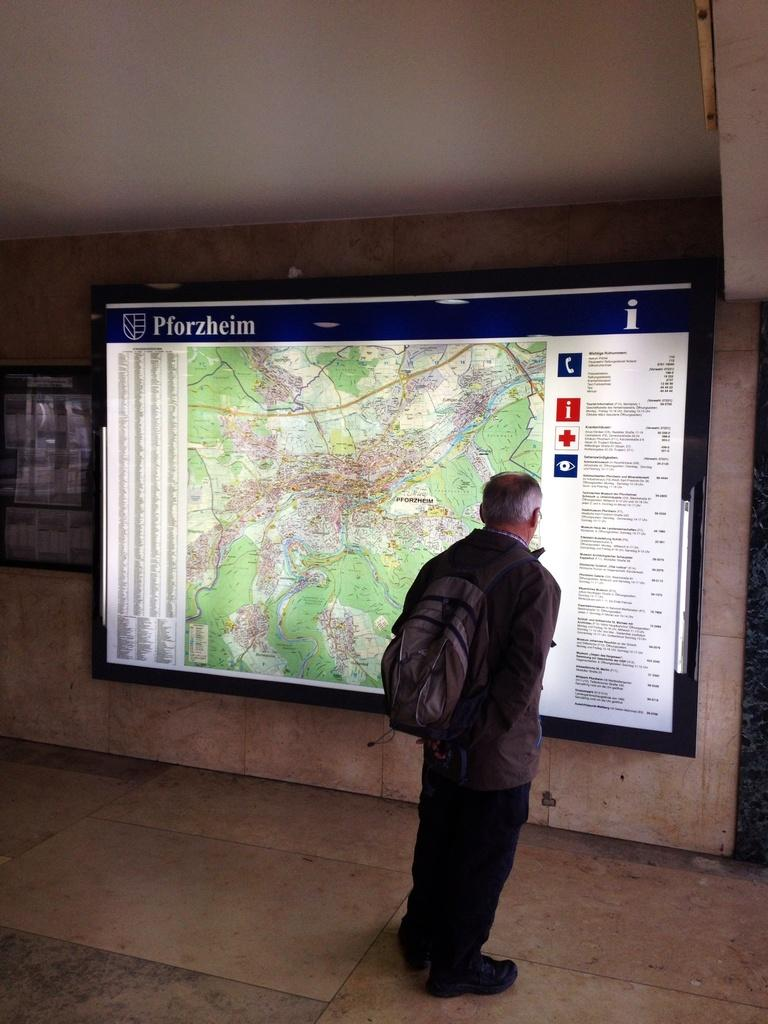What is the main subject of the image? There is a person standing in the image. Where is the person standing? The person is standing on the floor. What is the person wearing? The person is wearing a bag. What can be seen in the background of the image? There is a screen, a board, and a wall in the background of the image. What is the value of the harbor in the image? There is no harbor present in the image, so it is not possible to determine its value. 